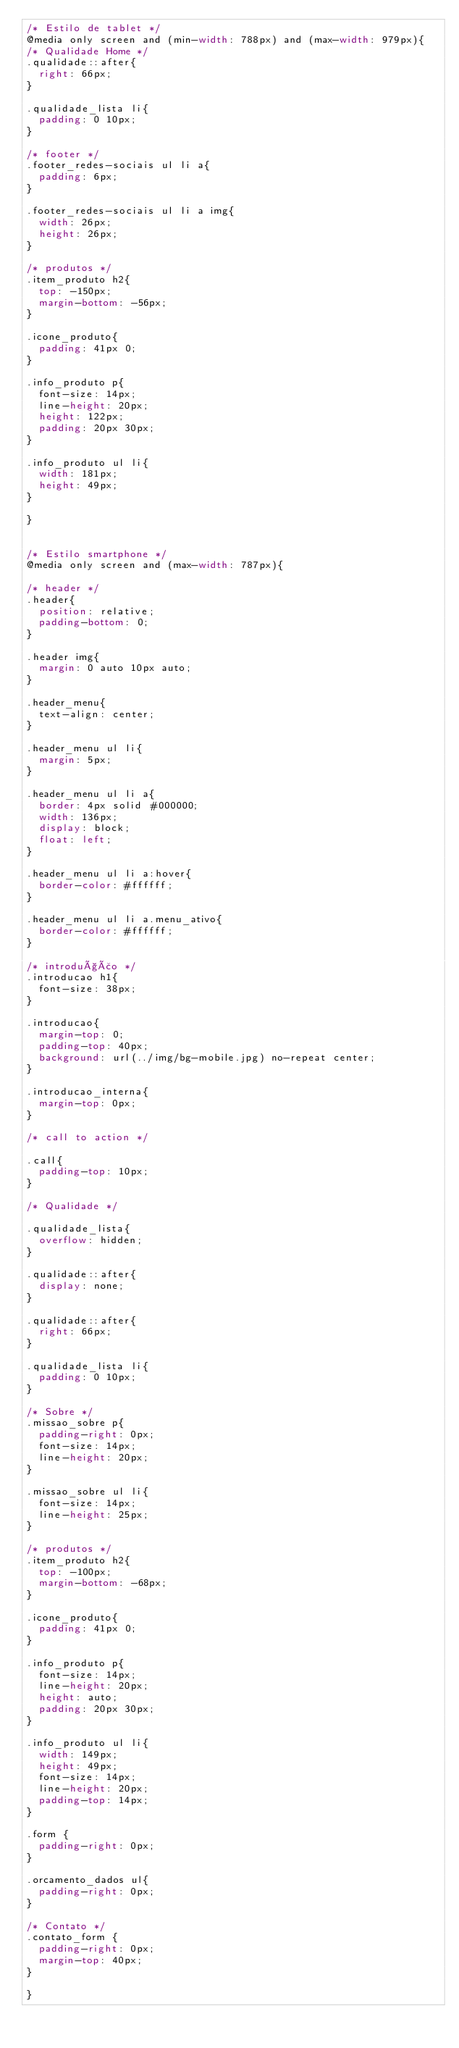Convert code to text. <code><loc_0><loc_0><loc_500><loc_500><_CSS_>/* Estilo de tablet */
@media only screen and (min-width: 788px) and (max-width: 979px){
/* Qualidade Home */
.qualidade::after{
  right: 66px;
}

.qualidade_lista li{
  padding: 0 10px;
}

/* footer */
.footer_redes-sociais ul li a{
  padding: 6px;
}

.footer_redes-sociais ul li a img{
  width: 26px;
  height: 26px;
}

/* produtos */
.item_produto h2{
  top: -150px;
  margin-bottom: -56px;
}

.icone_produto{
  padding: 41px 0;
}

.info_produto p{
  font-size: 14px;
  line-height: 20px;
  height: 122px;
  padding: 20px 30px;
}

.info_produto ul li{
  width: 181px;
  height: 49px;
}

}


/* Estilo smartphone */
@media only screen and (max-width: 787px){
  
/* header */
.header{
  position: relative;
  padding-bottom: 0;
}

.header img{
  margin: 0 auto 10px auto;
}

.header_menu{
  text-align: center;
}

.header_menu ul li{
  margin: 5px;
}

.header_menu ul li a{
  border: 4px solid #000000;
  width: 136px;
  display: block;
  float: left;
}

.header_menu ul li a:hover{
  border-color: #ffffff;
}

.header_menu ul li a.menu_ativo{
  border-color: #ffffff;
}

/* introdução */
.introducao h1{
  font-size: 38px;
}

.introducao{
  margin-top: 0;
  padding-top: 40px;
  background: url(../img/bg-mobile.jpg) no-repeat center;
}

.introducao_interna{
  margin-top: 0px;
}

/* call to action */

.call{
  padding-top: 10px;
}

/* Qualidade */

.qualidade_lista{
  overflow: hidden;
}

.qualidade::after{
  display: none;
}

.qualidade::after{
  right: 66px;
}

.qualidade_lista li{
  padding: 0 10px;
}

/* Sobre */
.missao_sobre p{
  padding-right: 0px;
  font-size: 14px;
  line-height: 20px;
}

.missao_sobre ul li{
  font-size: 14px;
  line-height: 25px;
}

/* produtos */
.item_produto h2{
  top: -100px;
  margin-bottom: -68px;
}

.icone_produto{
  padding: 41px 0;
}

.info_produto p{
  font-size: 14px;
  line-height: 20px;
  height: auto;
  padding: 20px 30px;
}

.info_produto ul li{
  width: 149px;
  height: 49px;
  font-size: 14px;
  line-height: 20px;
  padding-top: 14px;
}

.form {
  padding-right: 0px;
}

.orcamento_dados ul{
  padding-right: 0px;
}

/* Contato */
.contato_form {
  padding-right: 0px;
  margin-top: 40px;
}

}</code> 